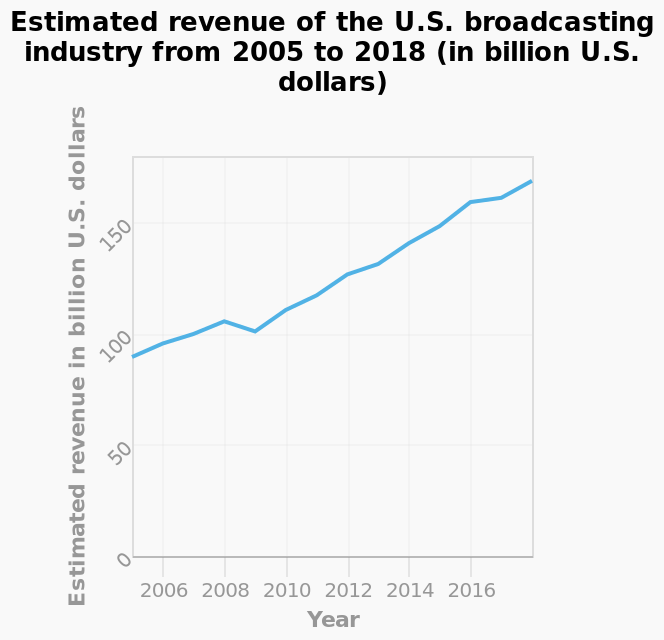<image>
Did the revenue of the US broadcasting industry consistently increase from 2005 to 2018? Yes, the revenue of the US broadcasting industry increased significantly during that period. In which year did the US broadcasting industry experience a decrease in revenue?  The US broadcasting industry experienced a decrease in revenue in 2008-2009. What happened to the revenue of the US broadcasting industry from 2005 to 2018?  The revenue of the US broadcasting industry increased significantly. 